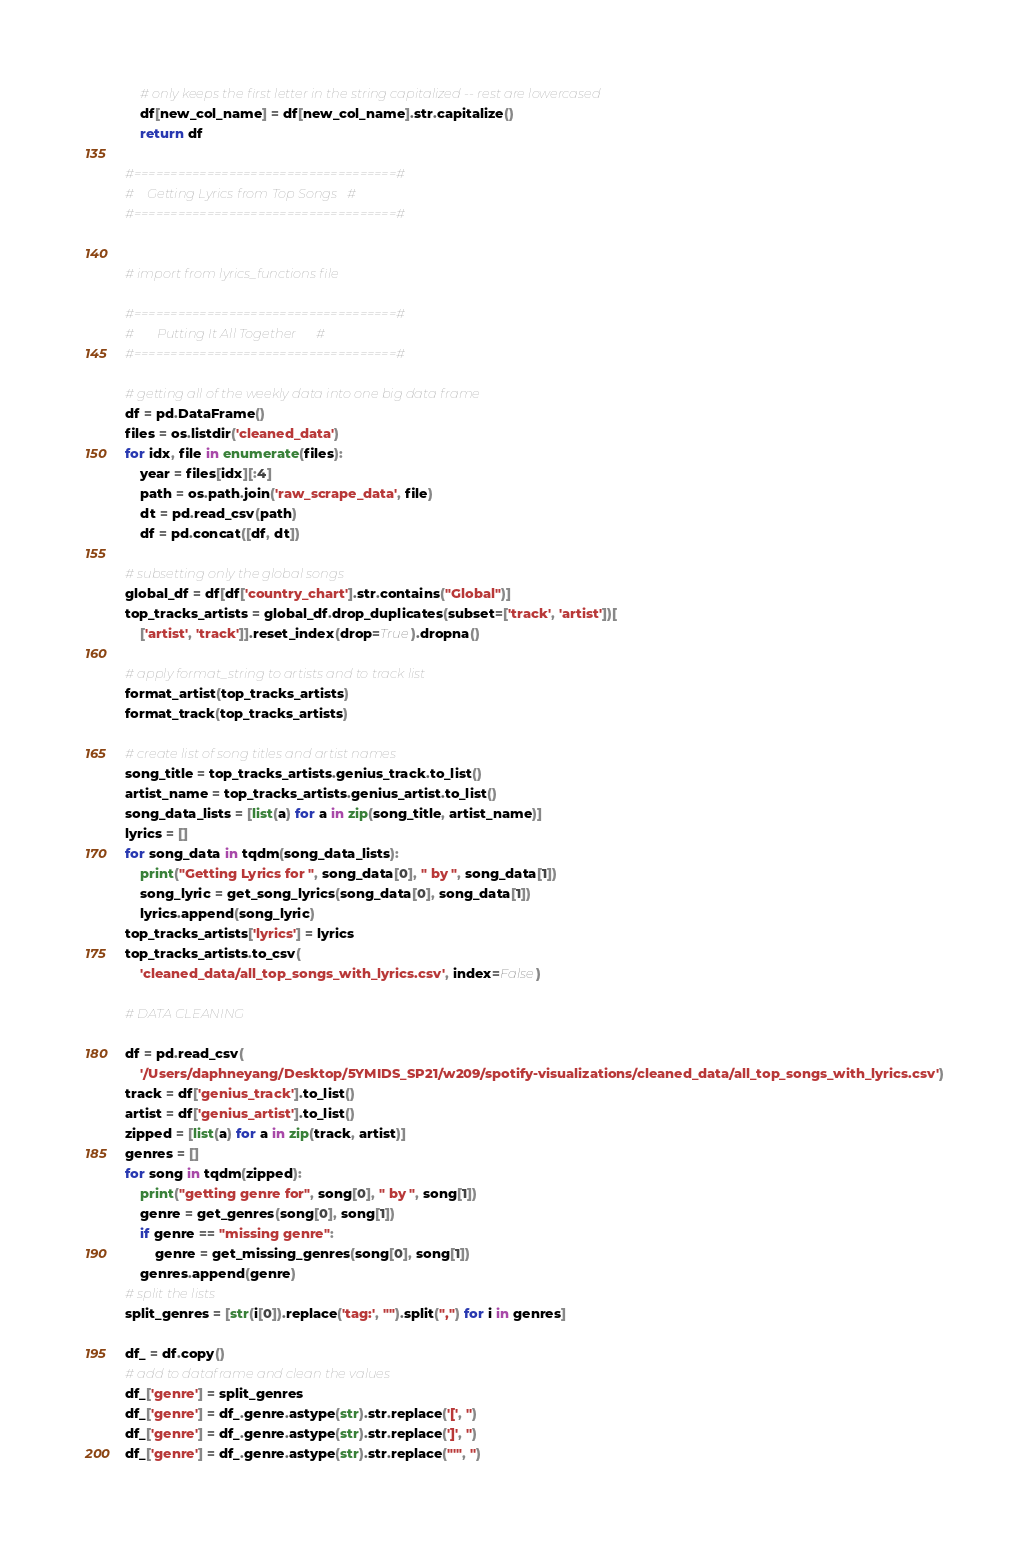Convert code to text. <code><loc_0><loc_0><loc_500><loc_500><_Python_>    # only keeps the first letter in the string capitalized -- rest are lowercased
    df[new_col_name] = df[new_col_name].str.capitalize()
    return df

#====================================#
#    Getting Lyrics from Top Songs   #
#====================================#


# import from lyrics_functions file

#====================================#
#       Putting It All Together      #
#====================================#

# getting all of the weekly data into one big data frame
df = pd.DataFrame()
files = os.listdir('cleaned_data')
for idx, file in enumerate(files):
    year = files[idx][:4]
    path = os.path.join('raw_scrape_data', file)
    dt = pd.read_csv(path)
    df = pd.concat([df, dt])

# subsetting only the global songs
global_df = df[df['country_chart'].str.contains("Global")]
top_tracks_artists = global_df.drop_duplicates(subset=['track', 'artist'])[
    ['artist', 'track']].reset_index(drop=True).dropna()

# apply format_string to artists and to track list
format_artist(top_tracks_artists)
format_track(top_tracks_artists)

# create list of song titles and artist names
song_title = top_tracks_artists.genius_track.to_list()
artist_name = top_tracks_artists.genius_artist.to_list()
song_data_lists = [list(a) for a in zip(song_title, artist_name)]
lyrics = []
for song_data in tqdm(song_data_lists):
    print("Getting Lyrics for ", song_data[0], " by ", song_data[1])
    song_lyric = get_song_lyrics(song_data[0], song_data[1])
    lyrics.append(song_lyric)
top_tracks_artists['lyrics'] = lyrics
top_tracks_artists.to_csv(
    'cleaned_data/all_top_songs_with_lyrics.csv', index=False)

# DATA CLEANING

df = pd.read_csv(
    '/Users/daphneyang/Desktop/5YMIDS_SP21/w209/spotify-visualizations/cleaned_data/all_top_songs_with_lyrics.csv')
track = df['genius_track'].to_list()
artist = df['genius_artist'].to_list()
zipped = [list(a) for a in zip(track, artist)]
genres = []
for song in tqdm(zipped):
    print("getting genre for", song[0], " by ", song[1])
    genre = get_genres(song[0], song[1])
    if genre == "missing genre":
        genre = get_missing_genres(song[0], song[1])
    genres.append(genre)
# split the lists
split_genres = [str(i[0]).replace('tag:', "").split(",") for i in genres]

df_ = df.copy()
# add to dataframe and clean the values
df_['genre'] = split_genres
df_['genre'] = df_.genre.astype(str).str.replace('[', '')
df_['genre'] = df_.genre.astype(str).str.replace(']', '')
df_['genre'] = df_.genre.astype(str).str.replace("'", '')
</code> 